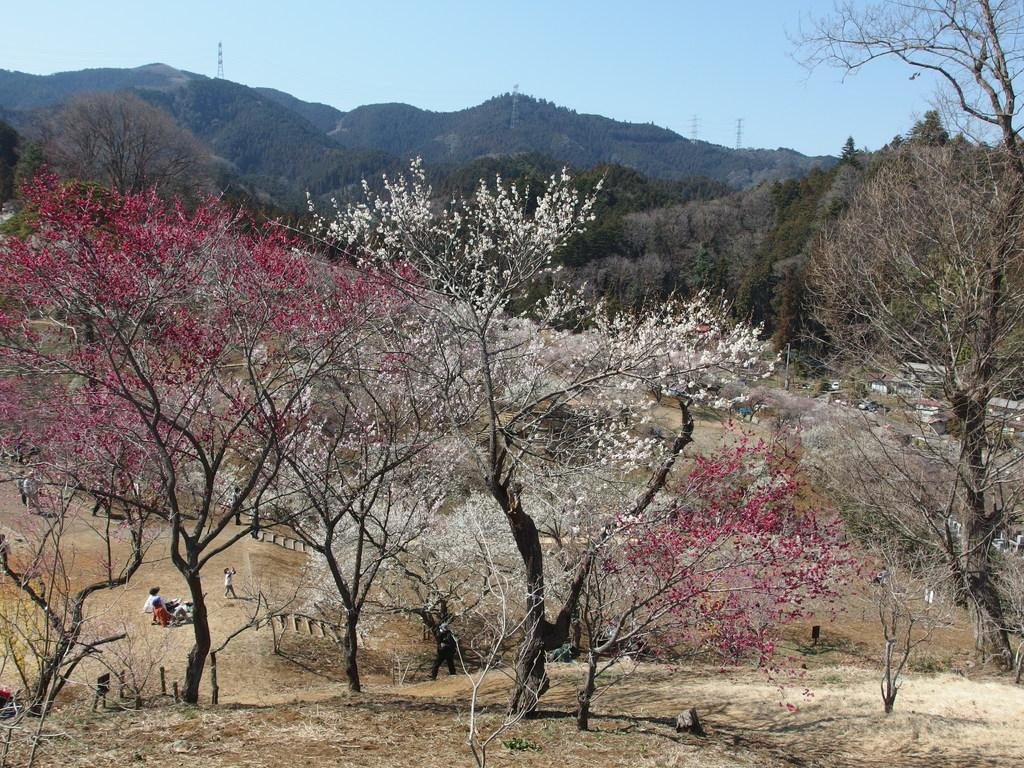What type of natural elements are present in the image? There are trees on a land in the image. What are the people in the image doing? Some people are lying on the land, while others are standing. What can be seen in the background of the image? There are mountains, towers, and the sky visible in the background. Where is the dock located in the image? There is no dock present in the image. What type of office can be seen in the background of the image? There is no office visible in the image; only mountains, towers, and the sky are present in the background. 